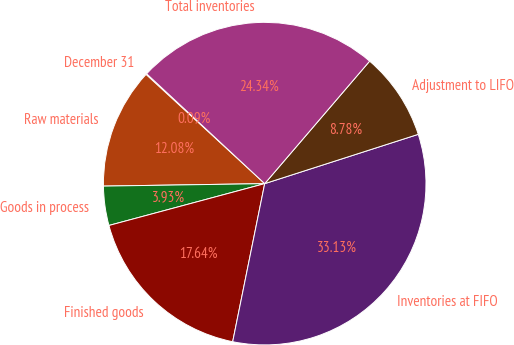Convert chart. <chart><loc_0><loc_0><loc_500><loc_500><pie_chart><fcel>December 31<fcel>Raw materials<fcel>Goods in process<fcel>Finished goods<fcel>Inventories at FIFO<fcel>Adjustment to LIFO<fcel>Total inventories<nl><fcel>0.09%<fcel>12.08%<fcel>3.93%<fcel>17.64%<fcel>33.12%<fcel>8.78%<fcel>24.34%<nl></chart> 